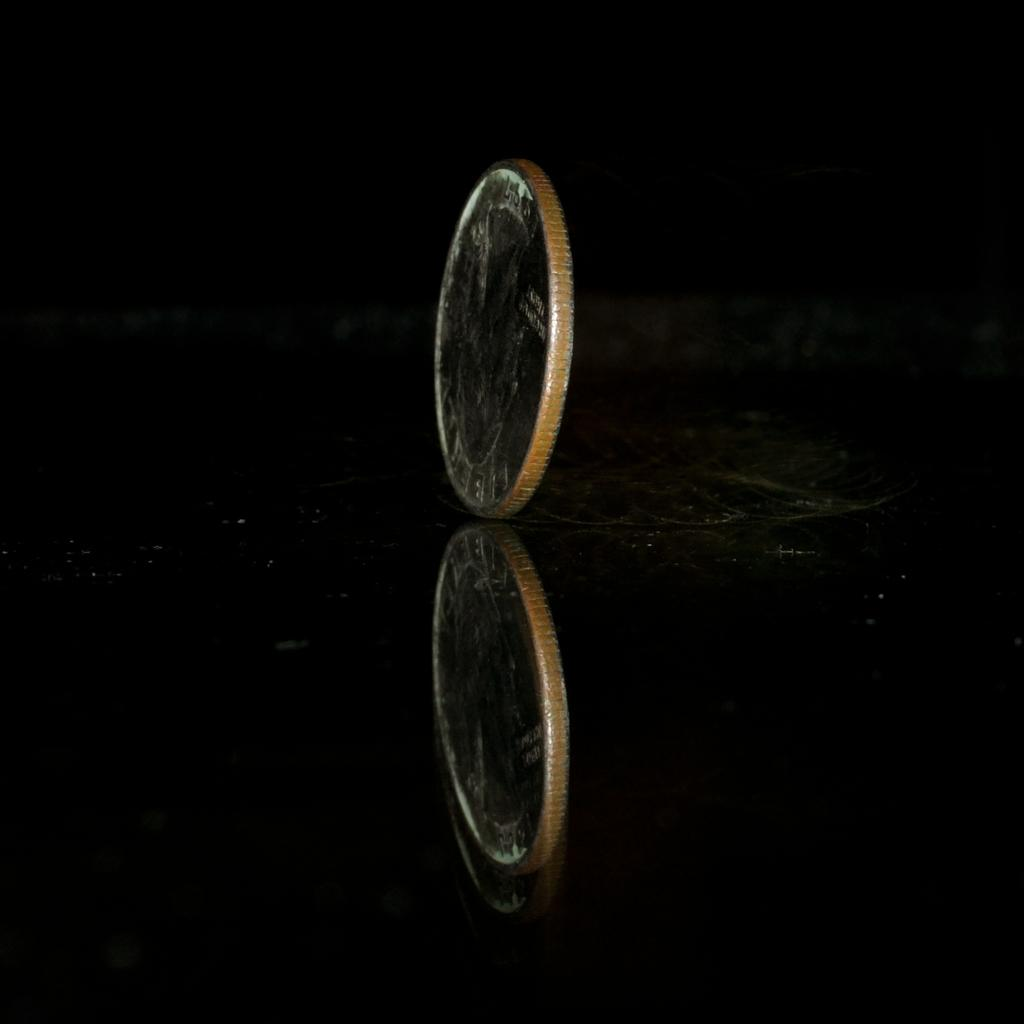What object is the main subject of the image? There is a coin in the image. How is the coin positioned in the image? The coin is in a vertical position. What is the coin resting on in the image? The coin is on black glass. Can you describe the coin's reflection in the image? The coin's reflection is visible in the front bottom side of the image. Is there a glove on the coin in the image? No, there is no glove present in the image. Can you see the person's elbow in the image? No, there is no person or elbow visible in the image. 